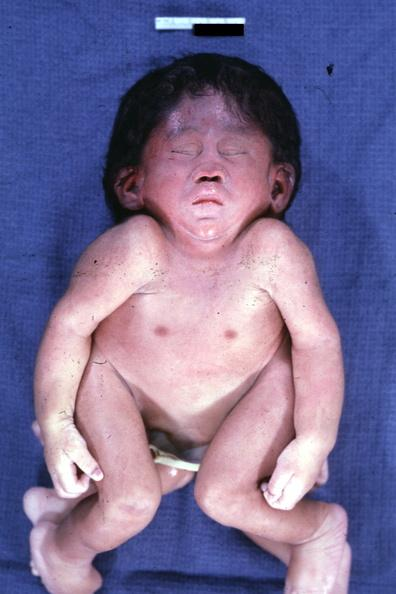what does this image show?
Answer the question using a single word or phrase. Conjoined twins at head and chest 